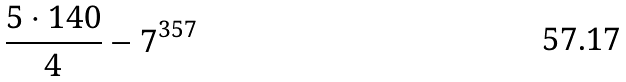<formula> <loc_0><loc_0><loc_500><loc_500>\frac { 5 \cdot 1 4 0 } { 4 } - 7 ^ { 3 5 7 }</formula> 